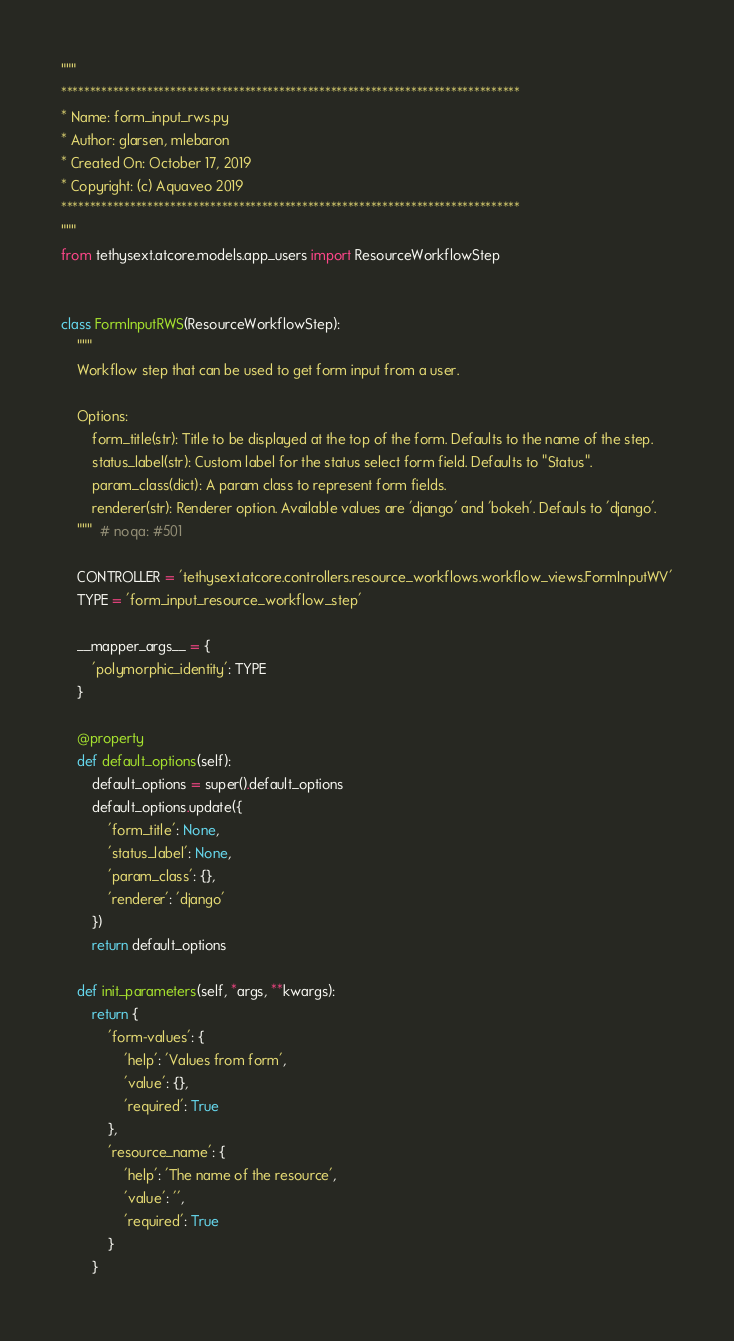Convert code to text. <code><loc_0><loc_0><loc_500><loc_500><_Python_>"""
********************************************************************************
* Name: form_input_rws.py
* Author: glarsen, mlebaron
* Created On: October 17, 2019
* Copyright: (c) Aquaveo 2019
********************************************************************************
"""
from tethysext.atcore.models.app_users import ResourceWorkflowStep


class FormInputRWS(ResourceWorkflowStep):
    """
    Workflow step that can be used to get form input from a user.

    Options:
        form_title(str): Title to be displayed at the top of the form. Defaults to the name of the step.
        status_label(str): Custom label for the status select form field. Defaults to "Status".
        param_class(dict): A param class to represent form fields.
        renderer(str): Renderer option. Available values are 'django' and 'bokeh'. Defauls to 'django'. 
    """  # noqa: #501

    CONTROLLER = 'tethysext.atcore.controllers.resource_workflows.workflow_views.FormInputWV'
    TYPE = 'form_input_resource_workflow_step'

    __mapper_args__ = {
        'polymorphic_identity': TYPE
    }

    @property
    def default_options(self):
        default_options = super().default_options
        default_options.update({
            'form_title': None,
            'status_label': None,
            'param_class': {},
            'renderer': 'django'
        })
        return default_options

    def init_parameters(self, *args, **kwargs):
        return {
            'form-values': {
                'help': 'Values from form',
                'value': {},
                'required': True
            },
            'resource_name': {
                'help': 'The name of the resource',
                'value': '',
                'required': True
            }
        }
</code> 